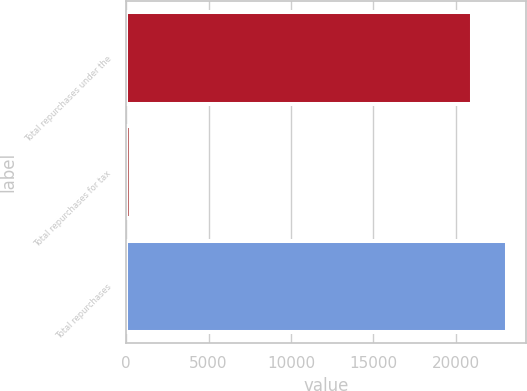Convert chart to OTSL. <chart><loc_0><loc_0><loc_500><loc_500><bar_chart><fcel>Total repurchases under the<fcel>Total repurchases for tax<fcel>Total repurchases<nl><fcel>21006<fcel>298<fcel>23106.6<nl></chart> 